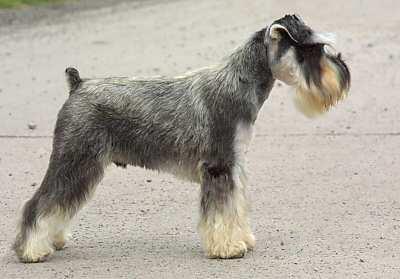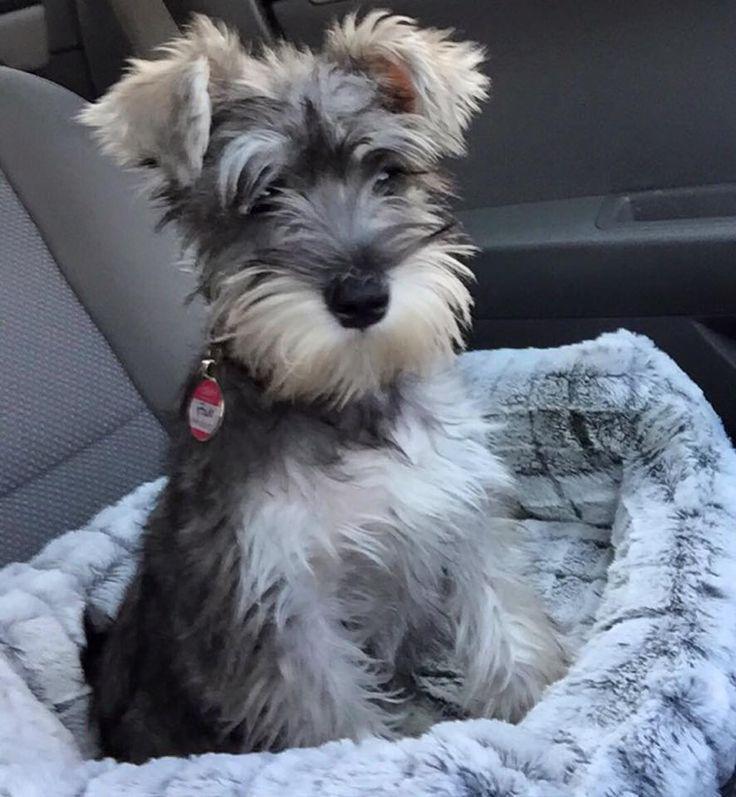The first image is the image on the left, the second image is the image on the right. Considering the images on both sides, is "One image shows a schnauzer standing and facing toward the right." valid? Answer yes or no. Yes. 